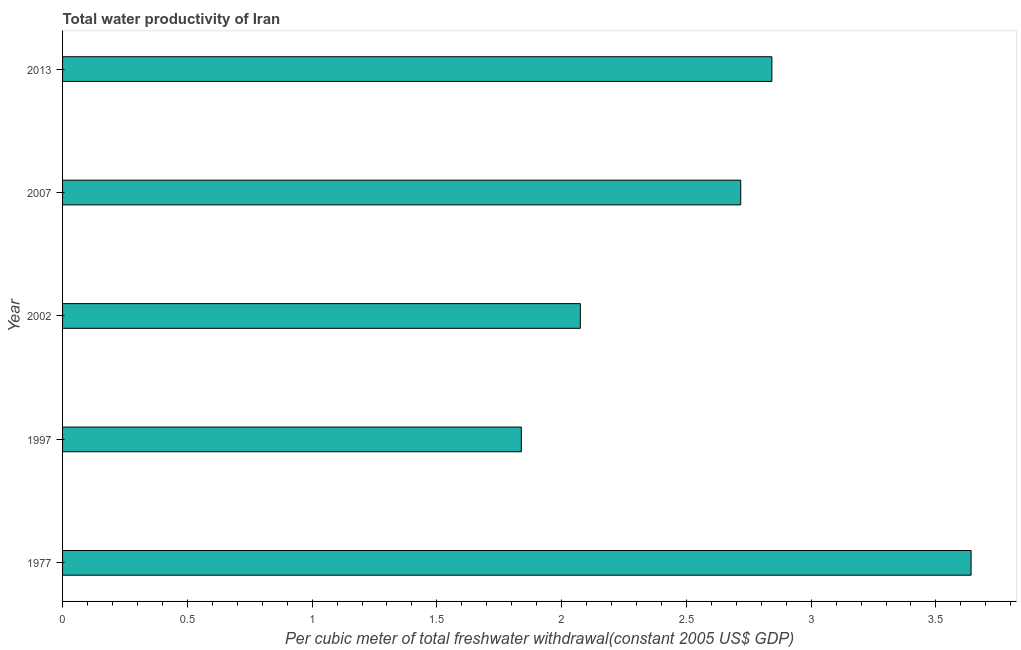Does the graph contain any zero values?
Your answer should be very brief. No. What is the title of the graph?
Your answer should be very brief. Total water productivity of Iran. What is the label or title of the X-axis?
Provide a short and direct response. Per cubic meter of total freshwater withdrawal(constant 2005 US$ GDP). What is the label or title of the Y-axis?
Keep it short and to the point. Year. What is the total water productivity in 1977?
Keep it short and to the point. 3.64. Across all years, what is the maximum total water productivity?
Your response must be concise. 3.64. Across all years, what is the minimum total water productivity?
Provide a short and direct response. 1.84. What is the sum of the total water productivity?
Give a very brief answer. 13.11. What is the difference between the total water productivity in 1997 and 2013?
Keep it short and to the point. -1. What is the average total water productivity per year?
Offer a terse response. 2.62. What is the median total water productivity?
Provide a succinct answer. 2.72. In how many years, is the total water productivity greater than 3.1 US$?
Ensure brevity in your answer.  1. Do a majority of the years between 1977 and 2007 (inclusive) have total water productivity greater than 3 US$?
Offer a terse response. No. What is the ratio of the total water productivity in 2002 to that in 2007?
Provide a short and direct response. 0.76. Is the difference between the total water productivity in 2002 and 2007 greater than the difference between any two years?
Ensure brevity in your answer.  No. What is the difference between the highest and the second highest total water productivity?
Offer a very short reply. 0.8. Is the sum of the total water productivity in 1977 and 2013 greater than the maximum total water productivity across all years?
Provide a succinct answer. Yes. In how many years, is the total water productivity greater than the average total water productivity taken over all years?
Offer a terse response. 3. How many years are there in the graph?
Offer a very short reply. 5. What is the difference between two consecutive major ticks on the X-axis?
Offer a terse response. 0.5. What is the Per cubic meter of total freshwater withdrawal(constant 2005 US$ GDP) in 1977?
Give a very brief answer. 3.64. What is the Per cubic meter of total freshwater withdrawal(constant 2005 US$ GDP) of 1997?
Make the answer very short. 1.84. What is the Per cubic meter of total freshwater withdrawal(constant 2005 US$ GDP) of 2002?
Your response must be concise. 2.07. What is the Per cubic meter of total freshwater withdrawal(constant 2005 US$ GDP) of 2007?
Provide a succinct answer. 2.72. What is the Per cubic meter of total freshwater withdrawal(constant 2005 US$ GDP) in 2013?
Offer a terse response. 2.84. What is the difference between the Per cubic meter of total freshwater withdrawal(constant 2005 US$ GDP) in 1977 and 1997?
Your answer should be compact. 1.8. What is the difference between the Per cubic meter of total freshwater withdrawal(constant 2005 US$ GDP) in 1977 and 2002?
Provide a succinct answer. 1.57. What is the difference between the Per cubic meter of total freshwater withdrawal(constant 2005 US$ GDP) in 1977 and 2007?
Your response must be concise. 0.92. What is the difference between the Per cubic meter of total freshwater withdrawal(constant 2005 US$ GDP) in 1977 and 2013?
Give a very brief answer. 0.8. What is the difference between the Per cubic meter of total freshwater withdrawal(constant 2005 US$ GDP) in 1997 and 2002?
Your answer should be compact. -0.24. What is the difference between the Per cubic meter of total freshwater withdrawal(constant 2005 US$ GDP) in 1997 and 2007?
Ensure brevity in your answer.  -0.88. What is the difference between the Per cubic meter of total freshwater withdrawal(constant 2005 US$ GDP) in 1997 and 2013?
Provide a short and direct response. -1. What is the difference between the Per cubic meter of total freshwater withdrawal(constant 2005 US$ GDP) in 2002 and 2007?
Your answer should be compact. -0.64. What is the difference between the Per cubic meter of total freshwater withdrawal(constant 2005 US$ GDP) in 2002 and 2013?
Your response must be concise. -0.77. What is the difference between the Per cubic meter of total freshwater withdrawal(constant 2005 US$ GDP) in 2007 and 2013?
Offer a terse response. -0.12. What is the ratio of the Per cubic meter of total freshwater withdrawal(constant 2005 US$ GDP) in 1977 to that in 1997?
Provide a succinct answer. 1.98. What is the ratio of the Per cubic meter of total freshwater withdrawal(constant 2005 US$ GDP) in 1977 to that in 2002?
Make the answer very short. 1.75. What is the ratio of the Per cubic meter of total freshwater withdrawal(constant 2005 US$ GDP) in 1977 to that in 2007?
Make the answer very short. 1.34. What is the ratio of the Per cubic meter of total freshwater withdrawal(constant 2005 US$ GDP) in 1977 to that in 2013?
Provide a succinct answer. 1.28. What is the ratio of the Per cubic meter of total freshwater withdrawal(constant 2005 US$ GDP) in 1997 to that in 2002?
Keep it short and to the point. 0.89. What is the ratio of the Per cubic meter of total freshwater withdrawal(constant 2005 US$ GDP) in 1997 to that in 2007?
Offer a terse response. 0.68. What is the ratio of the Per cubic meter of total freshwater withdrawal(constant 2005 US$ GDP) in 1997 to that in 2013?
Your answer should be very brief. 0.65. What is the ratio of the Per cubic meter of total freshwater withdrawal(constant 2005 US$ GDP) in 2002 to that in 2007?
Provide a short and direct response. 0.76. What is the ratio of the Per cubic meter of total freshwater withdrawal(constant 2005 US$ GDP) in 2002 to that in 2013?
Your response must be concise. 0.73. What is the ratio of the Per cubic meter of total freshwater withdrawal(constant 2005 US$ GDP) in 2007 to that in 2013?
Ensure brevity in your answer.  0.96. 